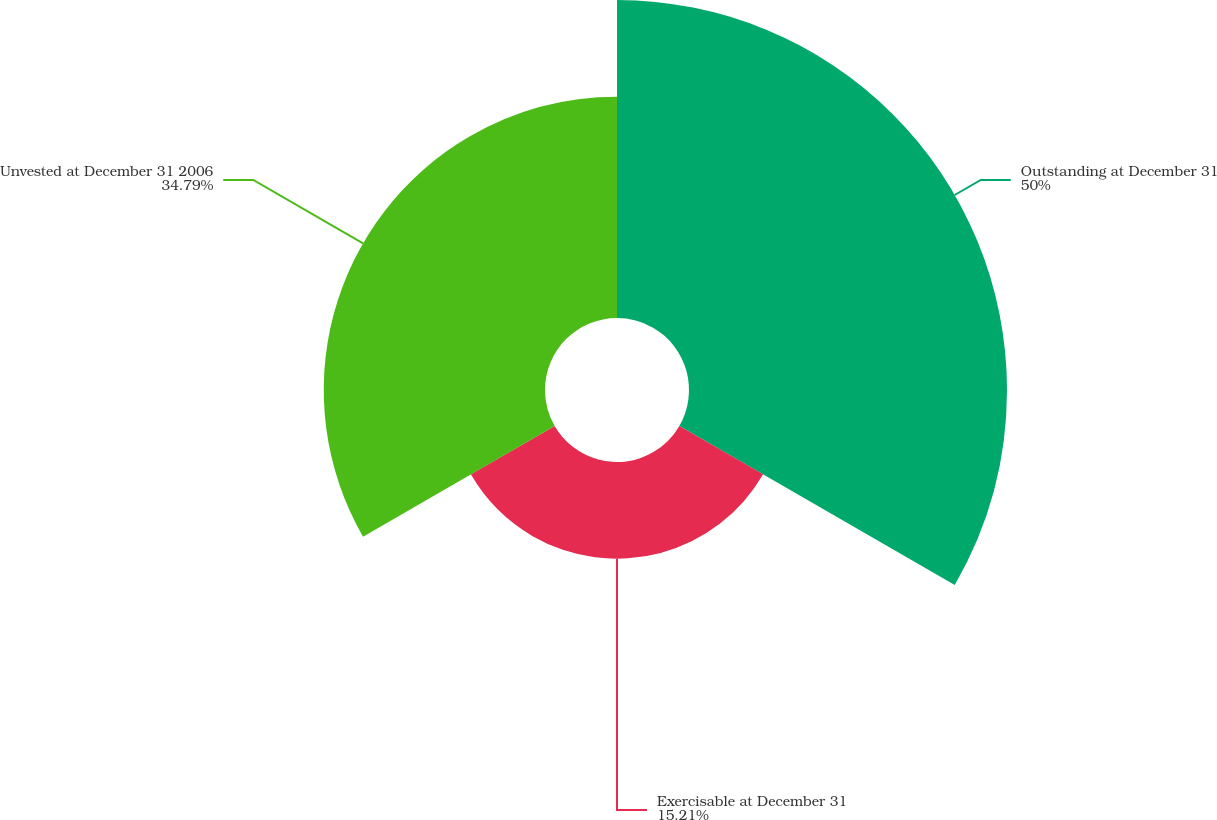<chart> <loc_0><loc_0><loc_500><loc_500><pie_chart><fcel>Outstanding at December 31<fcel>Exercisable at December 31<fcel>Unvested at December 31 2006<nl><fcel>50.0%<fcel>15.21%<fcel>34.79%<nl></chart> 